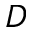<formula> <loc_0><loc_0><loc_500><loc_500>D</formula> 